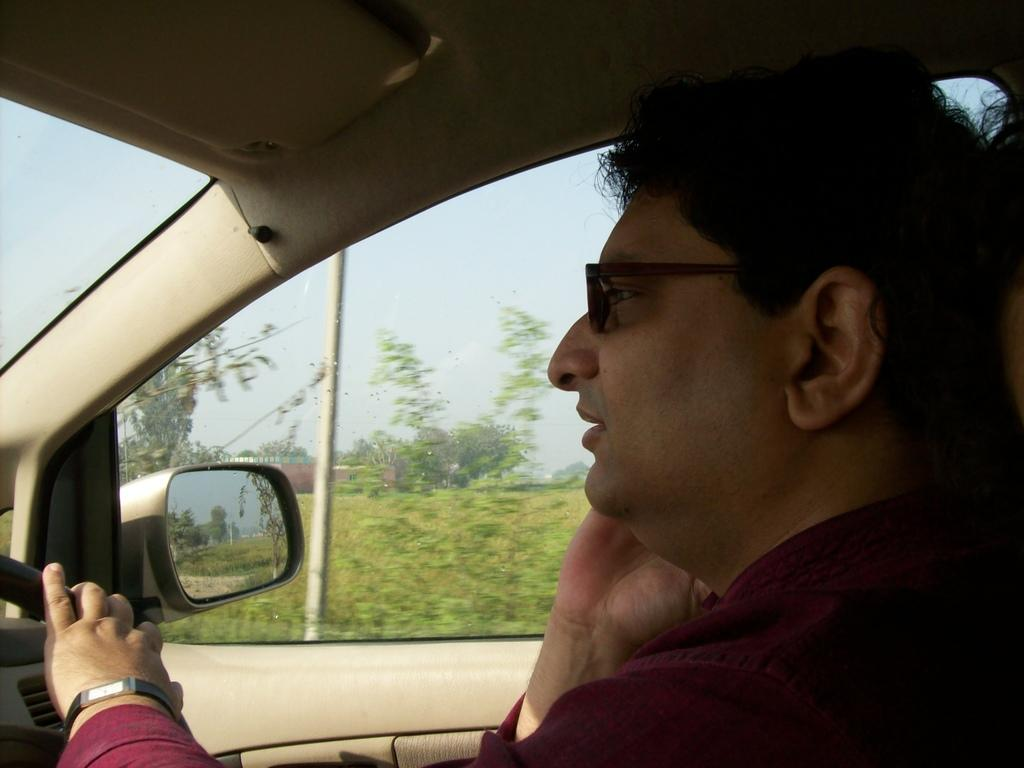What is the person in the image doing? The person is driving a car in the image. What object can be seen inside the car? There is a mirror in the image. What is the pole in the image used for? The purpose of the pole is not specified in the facts, but it is present in the image. What type of vegetation is visible in the image? There is grass in the image. What is visible in the background of the image? The sky, clouds, and trees are visible in the image. What type of wine is being served in the image? There is no mention of wine in the image or the provided facts. 